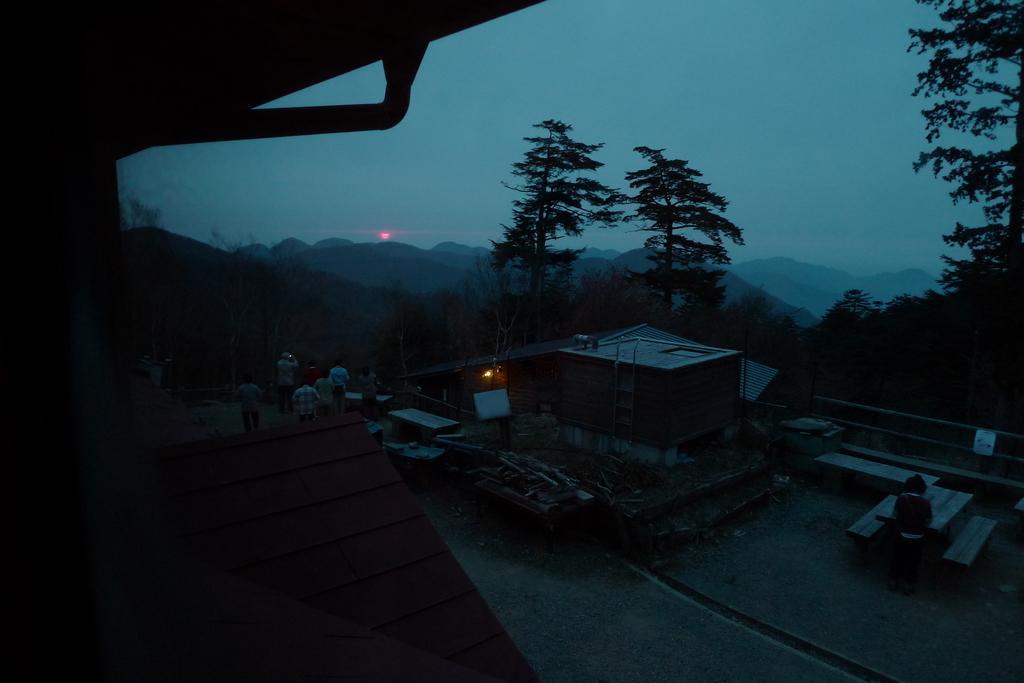In one or two sentences, can you explain what this image depicts? In this image there are a few people standing and taking pictures of the scenery and there is another person standing in front of a bench, in the background of the image there are trees and mountains. 